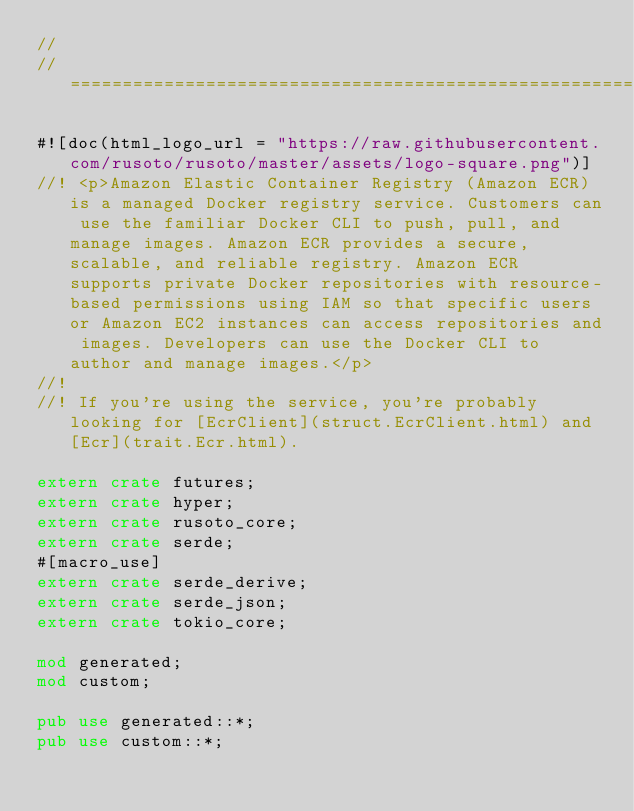<code> <loc_0><loc_0><loc_500><loc_500><_Rust_>//
// =================================================================

#![doc(html_logo_url = "https://raw.githubusercontent.com/rusoto/rusoto/master/assets/logo-square.png")]
//! <p>Amazon Elastic Container Registry (Amazon ECR) is a managed Docker registry service. Customers can use the familiar Docker CLI to push, pull, and manage images. Amazon ECR provides a secure, scalable, and reliable registry. Amazon ECR supports private Docker repositories with resource-based permissions using IAM so that specific users or Amazon EC2 instances can access repositories and images. Developers can use the Docker CLI to author and manage images.</p>
//!
//! If you're using the service, you're probably looking for [EcrClient](struct.EcrClient.html) and [Ecr](trait.Ecr.html).

extern crate futures;
extern crate hyper;
extern crate rusoto_core;
extern crate serde;
#[macro_use]
extern crate serde_derive;
extern crate serde_json;
extern crate tokio_core;

mod generated;
mod custom;

pub use generated::*;
pub use custom::*;
            
</code> 